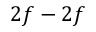Convert formula to latex. <formula><loc_0><loc_0><loc_500><loc_500>2 f - 2 f</formula> 